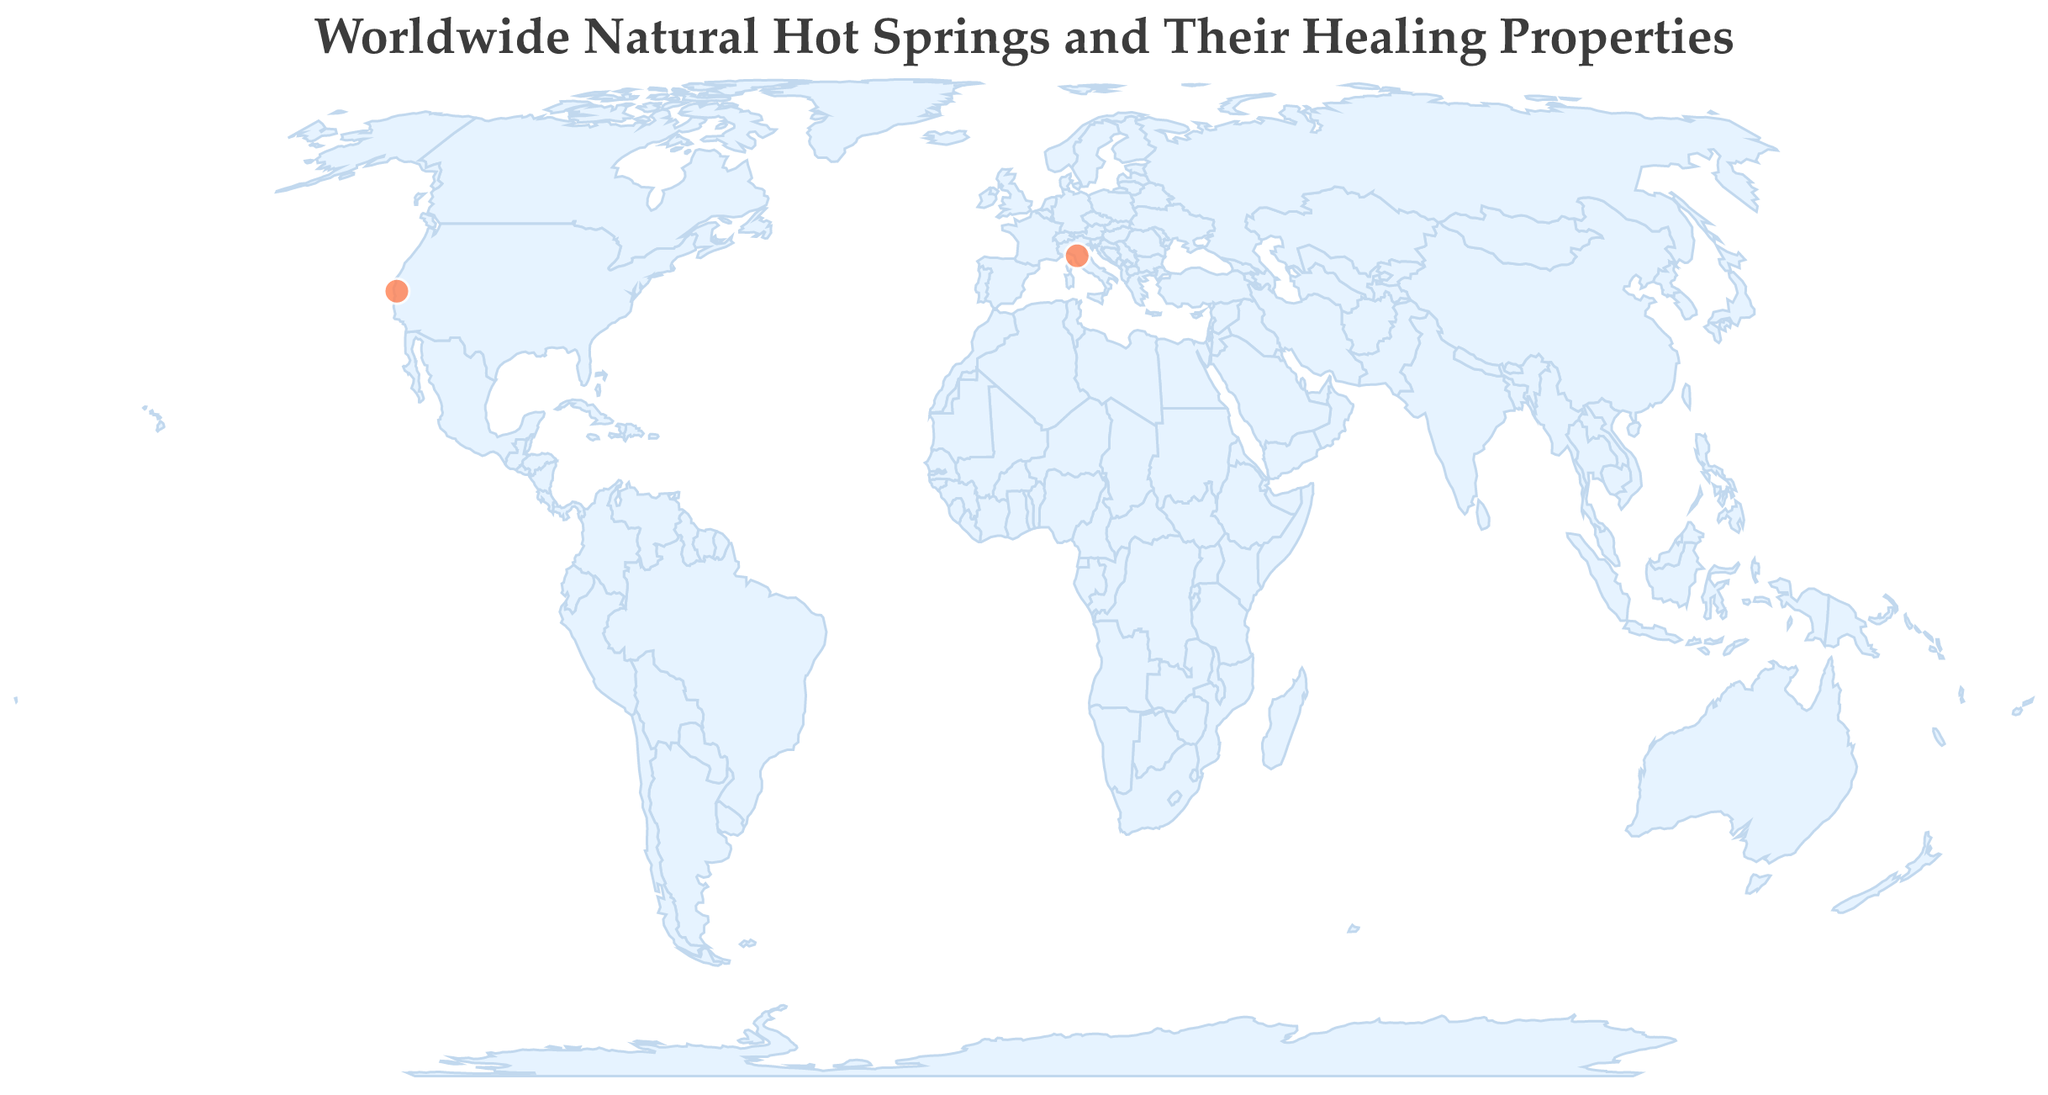What is the title of the figure? The title can be found at the top of the geographic plot, rendered in a distinctive font.
Answer: Worldwide Natural Hot Springs and Their Healing Properties How many hot springs are displayed on the map? By counting the circle markers representing hot springs on the map, you can determine the total number.
Answer: 2 Which hot spring is located in the USA? Referring to the tooltip or the location labeled on the map with a circle marker in the region corresponding to the USA shows the answer.
Answer: Calistoga Hot Springs What is the healing property of Terme di Saturnia in Italy? The information presented in the tooltip when hovering over the circle marker representing Terme di Saturnia will provide the answer.
Answer: Digestive health Which hot spring has the healing property of "Detoxification"? By examining the tooltip associated with the different markers on the map, you can identify the hot spring with this specific healing property.
Answer: Calistoga Hot Springs Compare the healing properties provided by Calistoga Hot Springs and Terme di Saturnia. What are they? The tooltip associated with each hot spring on the map will display their respective healing properties, allowing for a direct comparison.
Answer: Detoxification and Digestive health Which continent has a hot spring represented on the map? Observing the circle markers' geographic locations on the map reveals the continents on which these hot springs are located.
Answer: North America and Europe Which hot spring's zen wisdom is "Nourish the body to feed the soul"? Hovering over the circle markers to view the tooltip revealing the zen wisdom will show the hot spring associated with this wisdom.
Answer: Terme di Saturnia Identify a specific country shown in the map where a hot spring with "Detoxification" healing property is located. The tooltip containing the details about the hot spring's healing property and location will provide the country name.
Answer: USA Determine the latitude and longitude of the hot spring known for digestive health. The geographic coordinates are given in the tooltip when the marker for the hot spring with digestive health is examined.
Answer: 43.8791 and 10.7764 